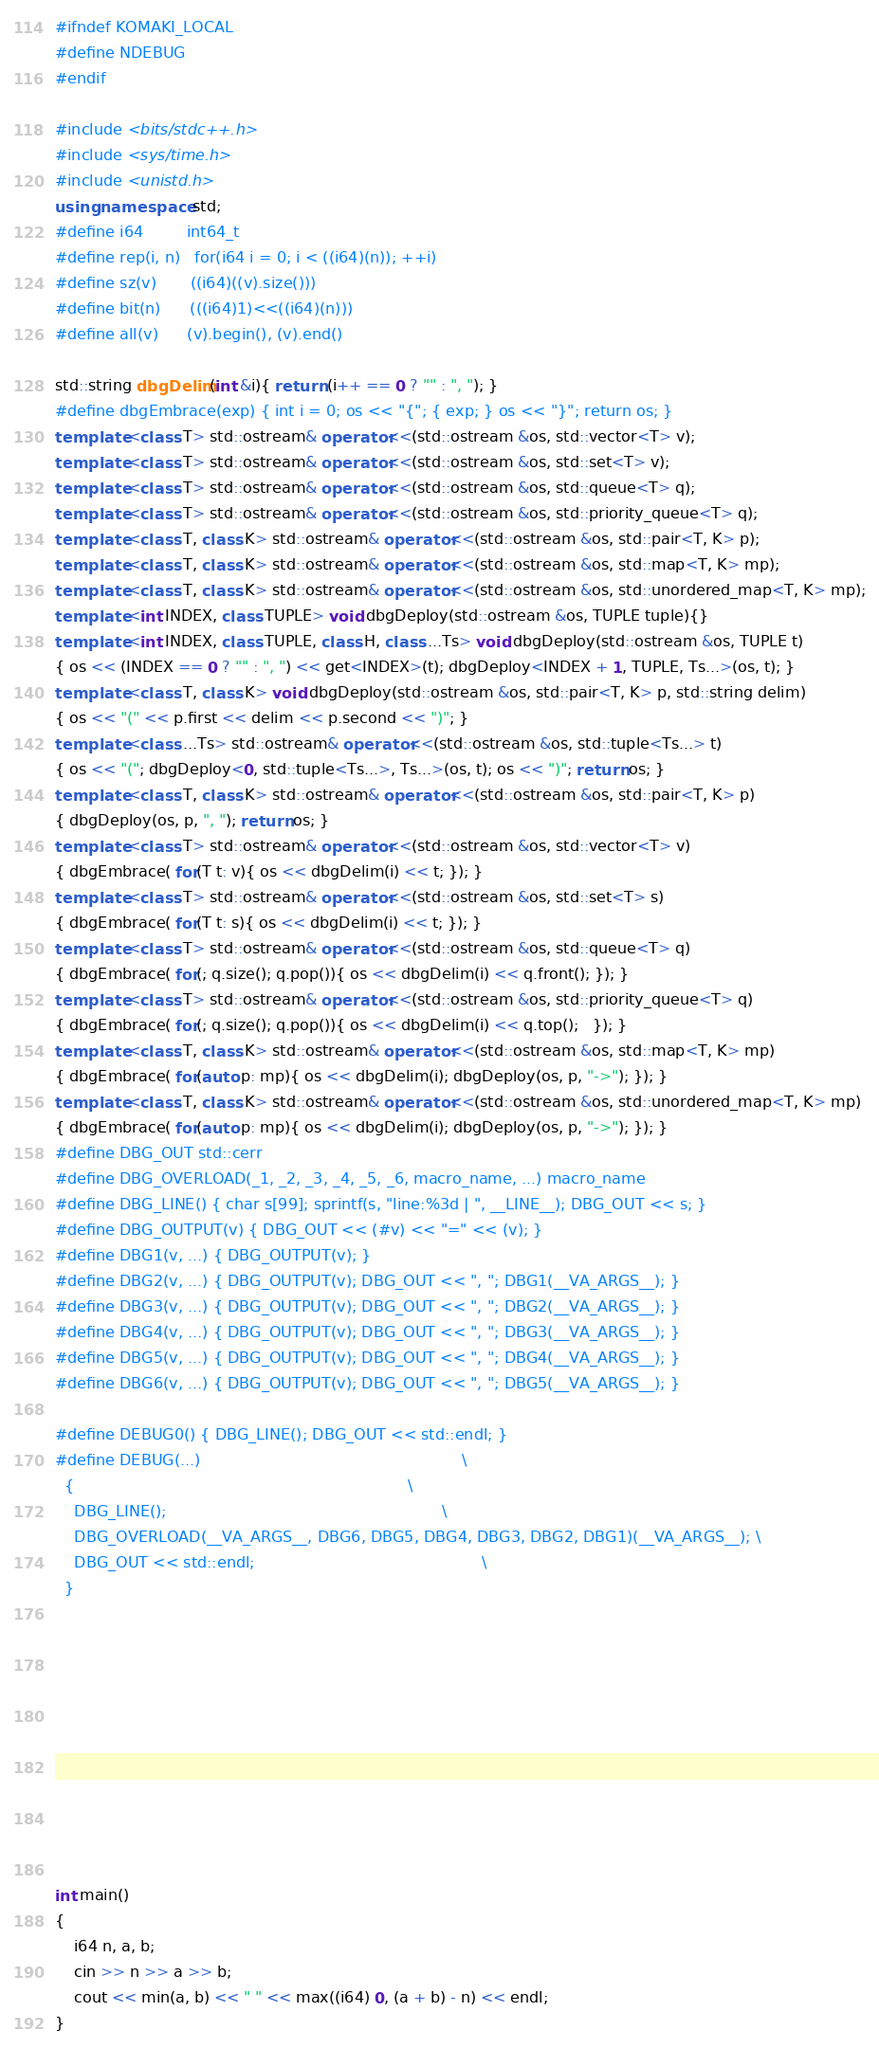<code> <loc_0><loc_0><loc_500><loc_500><_C++_>#ifndef KOMAKI_LOCAL
#define NDEBUG
#endif

#include <bits/stdc++.h>
#include <sys/time.h>
#include <unistd.h>
using namespace std;
#define i64         int64_t
#define rep(i, n)   for(i64 i = 0; i < ((i64)(n)); ++i)
#define sz(v)       ((i64)((v).size()))
#define bit(n)      (((i64)1)<<((i64)(n)))
#define all(v)      (v).begin(), (v).end()

std::string dbgDelim(int &i){ return (i++ == 0 ? "" : ", "); }
#define dbgEmbrace(exp) { int i = 0; os << "{"; { exp; } os << "}"; return os; }
template <class T> std::ostream& operator<<(std::ostream &os, std::vector<T> v);
template <class T> std::ostream& operator<<(std::ostream &os, std::set<T> v);
template <class T> std::ostream& operator<<(std::ostream &os, std::queue<T> q);
template <class T> std::ostream& operator<<(std::ostream &os, std::priority_queue<T> q);
template <class T, class K> std::ostream& operator<<(std::ostream &os, std::pair<T, K> p);
template <class T, class K> std::ostream& operator<<(std::ostream &os, std::map<T, K> mp);
template <class T, class K> std::ostream& operator<<(std::ostream &os, std::unordered_map<T, K> mp);
template <int INDEX, class TUPLE> void dbgDeploy(std::ostream &os, TUPLE tuple){}
template <int INDEX, class TUPLE, class H, class ...Ts> void dbgDeploy(std::ostream &os, TUPLE t)
{ os << (INDEX == 0 ? "" : ", ") << get<INDEX>(t); dbgDeploy<INDEX + 1, TUPLE, Ts...>(os, t); }
template <class T, class K> void dbgDeploy(std::ostream &os, std::pair<T, K> p, std::string delim)
{ os << "(" << p.first << delim << p.second << ")"; }
template <class ...Ts> std::ostream& operator<<(std::ostream &os, std::tuple<Ts...> t)
{ os << "("; dbgDeploy<0, std::tuple<Ts...>, Ts...>(os, t); os << ")"; return os; }
template <class T, class K> std::ostream& operator<<(std::ostream &os, std::pair<T, K> p)
{ dbgDeploy(os, p, ", "); return os; }
template <class T> std::ostream& operator<<(std::ostream &os, std::vector<T> v)
{ dbgEmbrace( for(T t: v){ os << dbgDelim(i) << t; }); }
template <class T> std::ostream& operator<<(std::ostream &os, std::set<T> s)
{ dbgEmbrace( for(T t: s){ os << dbgDelim(i) << t; }); }
template <class T> std::ostream& operator<<(std::ostream &os, std::queue<T> q)
{ dbgEmbrace( for(; q.size(); q.pop()){ os << dbgDelim(i) << q.front(); }); }
template <class T> std::ostream& operator<<(std::ostream &os, std::priority_queue<T> q)
{ dbgEmbrace( for(; q.size(); q.pop()){ os << dbgDelim(i) << q.top();   }); }
template <class T, class K> std::ostream& operator<<(std::ostream &os, std::map<T, K> mp)
{ dbgEmbrace( for(auto p: mp){ os << dbgDelim(i); dbgDeploy(os, p, "->"); }); }
template <class T, class K> std::ostream& operator<<(std::ostream &os, std::unordered_map<T, K> mp)
{ dbgEmbrace( for(auto p: mp){ os << dbgDelim(i); dbgDeploy(os, p, "->"); }); }
#define DBG_OUT std::cerr
#define DBG_OVERLOAD(_1, _2, _3, _4, _5, _6, macro_name, ...) macro_name
#define DBG_LINE() { char s[99]; sprintf(s, "line:%3d | ", __LINE__); DBG_OUT << s; }
#define DBG_OUTPUT(v) { DBG_OUT << (#v) << "=" << (v); }
#define DBG1(v, ...) { DBG_OUTPUT(v); }
#define DBG2(v, ...) { DBG_OUTPUT(v); DBG_OUT << ", "; DBG1(__VA_ARGS__); }
#define DBG3(v, ...) { DBG_OUTPUT(v); DBG_OUT << ", "; DBG2(__VA_ARGS__); }
#define DBG4(v, ...) { DBG_OUTPUT(v); DBG_OUT << ", "; DBG3(__VA_ARGS__); }
#define DBG5(v, ...) { DBG_OUTPUT(v); DBG_OUT << ", "; DBG4(__VA_ARGS__); }
#define DBG6(v, ...) { DBG_OUTPUT(v); DBG_OUT << ", "; DBG5(__VA_ARGS__); }

#define DEBUG0() { DBG_LINE(); DBG_OUT << std::endl; }
#define DEBUG(...)                                                      \
  {                                                                     \
    DBG_LINE();                                                         \
    DBG_OVERLOAD(__VA_ARGS__, DBG6, DBG5, DBG4, DBG3, DBG2, DBG1)(__VA_ARGS__); \
    DBG_OUT << std::endl;                                               \
  }











int main()
{
    i64 n, a, b;
    cin >> n >> a >> b;
    cout << min(a, b) << " " << max((i64) 0, (a + b) - n) << endl;
}












</code> 